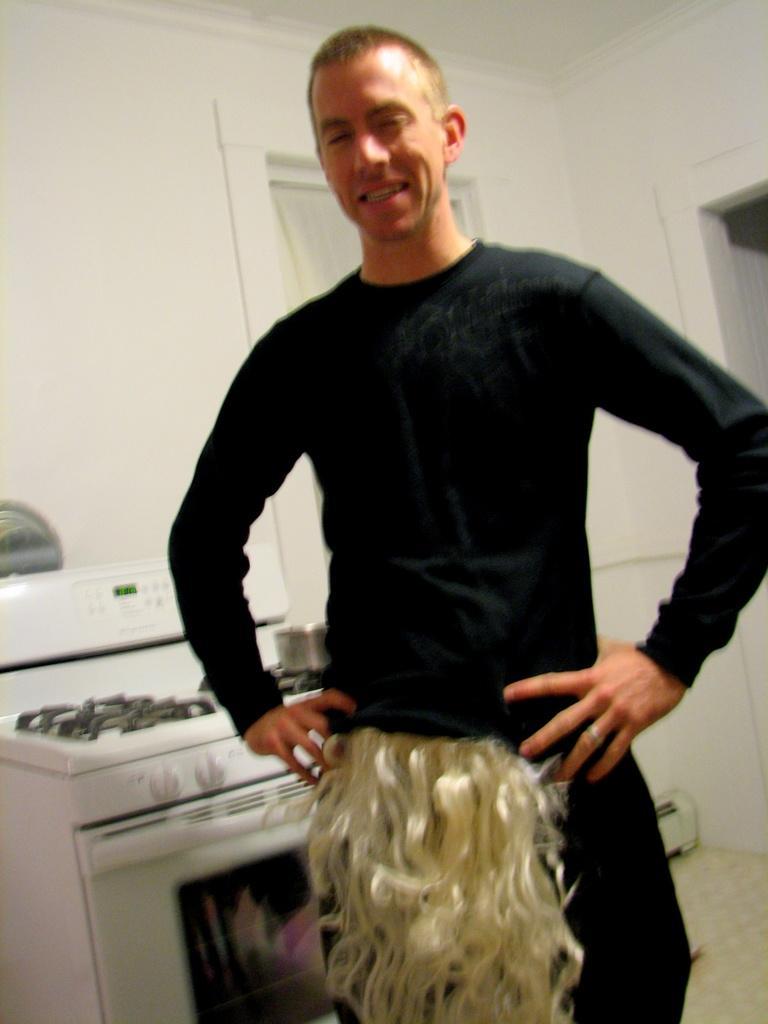How would you summarize this image in a sentence or two? In this image in the center there is one person standing, and in the background there is a stove. On the stove there is one bowl, and at the bottom there is a cupboard and in the background there is wall and some objects. At the bottom there is floor. 